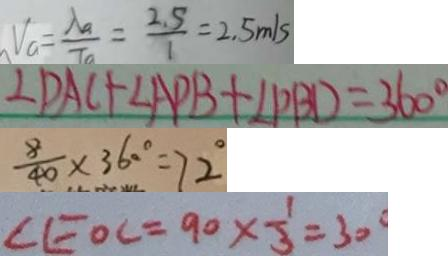<formula> <loc_0><loc_0><loc_500><loc_500>V _ { a } = \frac { \lambda _ { a } } { T _ { a } } = \frac { 2 . 5 } { 1 } = 2 . 5 m / s 
 \angle D A C + \angle A P B + \angle P B D = 3 6 0 ^ { \circ } 
 \frac { 8 } { 4 0 } \times 3 6 0 ^ { \circ } = 7 2 ^ { \circ } 
 \angle E O C = 9 0 \times \frac { 1 } { 3 } = 3 0 ^ { \circ }</formula> 